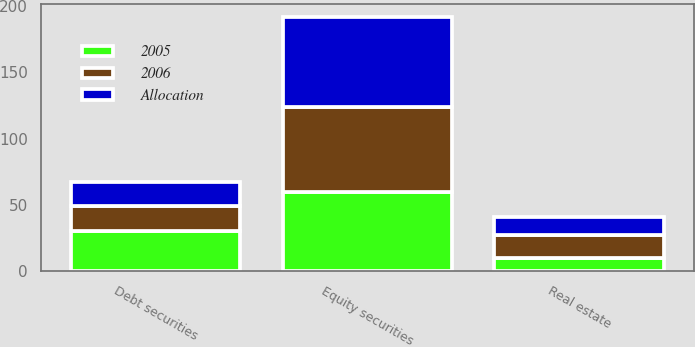Convert chart to OTSL. <chart><loc_0><loc_0><loc_500><loc_500><stacked_bar_chart><ecel><fcel>Equity securities<fcel>Debt securities<fcel>Real estate<nl><fcel>2005<fcel>60<fcel>30<fcel>10<nl><fcel>2006<fcel>64<fcel>19<fcel>17<nl><fcel>Allocation<fcel>68<fcel>18<fcel>14<nl></chart> 